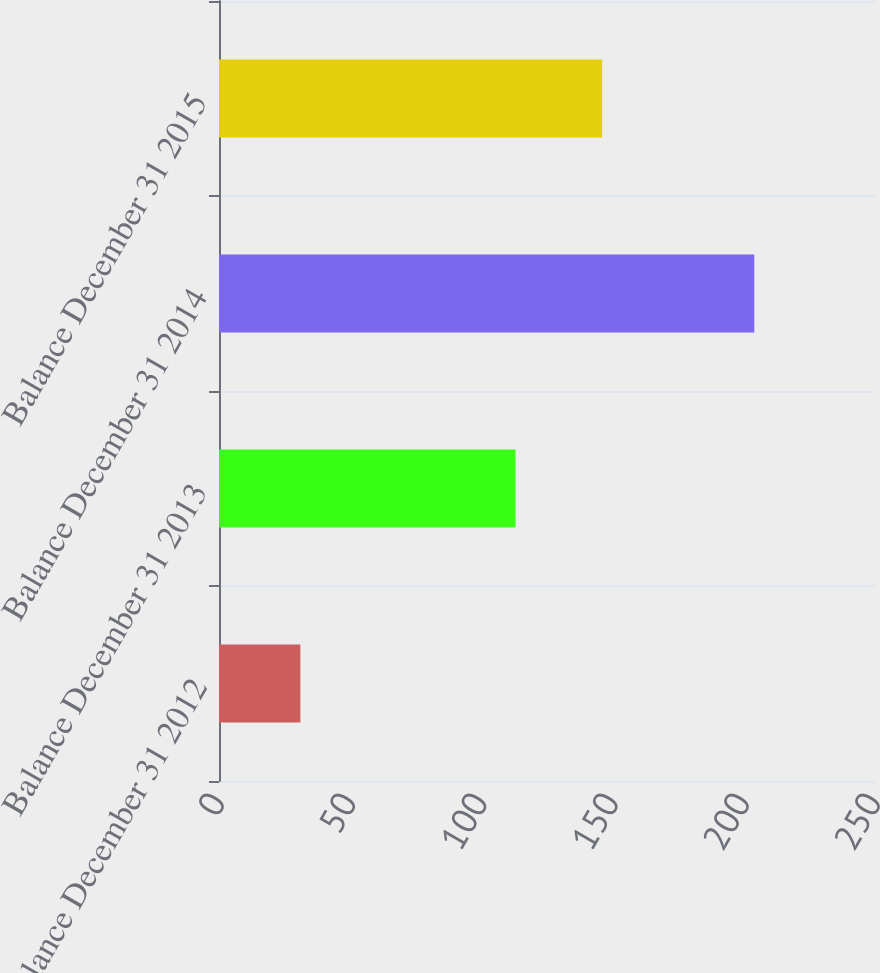Convert chart to OTSL. <chart><loc_0><loc_0><loc_500><loc_500><bar_chart><fcel>Balance December 31 2012<fcel>Balance December 31 2013<fcel>Balance December 31 2014<fcel>Balance December 31 2015<nl><fcel>31<fcel>113<fcel>204<fcel>146<nl></chart> 